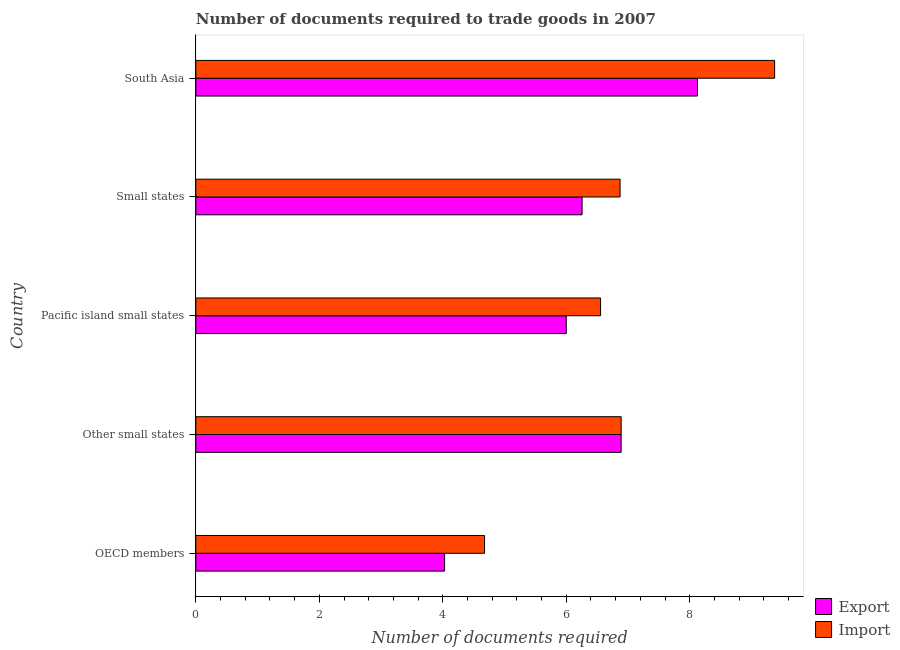How many groups of bars are there?
Your answer should be very brief. 5. Are the number of bars per tick equal to the number of legend labels?
Provide a short and direct response. Yes. How many bars are there on the 3rd tick from the top?
Offer a very short reply. 2. What is the number of documents required to export goods in South Asia?
Provide a succinct answer. 8.12. Across all countries, what is the maximum number of documents required to import goods?
Provide a short and direct response. 9.38. Across all countries, what is the minimum number of documents required to import goods?
Keep it short and to the point. 4.68. What is the total number of documents required to export goods in the graph?
Your response must be concise. 31.3. What is the difference between the number of documents required to export goods in Pacific island small states and that in Small states?
Your answer should be compact. -0.26. What is the difference between the number of documents required to import goods in South Asia and the number of documents required to export goods in Small states?
Make the answer very short. 3.12. What is the average number of documents required to import goods per country?
Make the answer very short. 6.87. What is the difference between the number of documents required to import goods and number of documents required to export goods in OECD members?
Provide a short and direct response. 0.65. What is the ratio of the number of documents required to export goods in Pacific island small states to that in South Asia?
Your answer should be very brief. 0.74. Is the number of documents required to import goods in OECD members less than that in Small states?
Your response must be concise. Yes. What is the difference between the highest and the second highest number of documents required to export goods?
Your answer should be compact. 1.24. In how many countries, is the number of documents required to export goods greater than the average number of documents required to export goods taken over all countries?
Offer a very short reply. 2. Is the sum of the number of documents required to export goods in OECD members and South Asia greater than the maximum number of documents required to import goods across all countries?
Provide a succinct answer. Yes. What does the 2nd bar from the top in Small states represents?
Offer a terse response. Export. What does the 2nd bar from the bottom in OECD members represents?
Give a very brief answer. Import. Are all the bars in the graph horizontal?
Keep it short and to the point. Yes. How many countries are there in the graph?
Ensure brevity in your answer.  5. Does the graph contain any zero values?
Offer a terse response. No. Where does the legend appear in the graph?
Offer a terse response. Bottom right. How many legend labels are there?
Your answer should be very brief. 2. How are the legend labels stacked?
Give a very brief answer. Vertical. What is the title of the graph?
Your response must be concise. Number of documents required to trade goods in 2007. What is the label or title of the X-axis?
Give a very brief answer. Number of documents required. What is the Number of documents required in Export in OECD members?
Give a very brief answer. 4.03. What is the Number of documents required in Import in OECD members?
Give a very brief answer. 4.68. What is the Number of documents required of Export in Other small states?
Give a very brief answer. 6.89. What is the Number of documents required in Import in Other small states?
Provide a short and direct response. 6.89. What is the Number of documents required in Export in Pacific island small states?
Offer a very short reply. 6. What is the Number of documents required of Import in Pacific island small states?
Your response must be concise. 6.56. What is the Number of documents required in Export in Small states?
Ensure brevity in your answer.  6.26. What is the Number of documents required in Import in Small states?
Your response must be concise. 6.87. What is the Number of documents required of Export in South Asia?
Your answer should be compact. 8.12. What is the Number of documents required in Import in South Asia?
Your answer should be compact. 9.38. Across all countries, what is the maximum Number of documents required of Export?
Your response must be concise. 8.12. Across all countries, what is the maximum Number of documents required of Import?
Your response must be concise. 9.38. Across all countries, what is the minimum Number of documents required of Export?
Provide a succinct answer. 4.03. Across all countries, what is the minimum Number of documents required of Import?
Ensure brevity in your answer.  4.68. What is the total Number of documents required of Export in the graph?
Make the answer very short. 31.3. What is the total Number of documents required of Import in the graph?
Offer a terse response. 34.37. What is the difference between the Number of documents required of Export in OECD members and that in Other small states?
Ensure brevity in your answer.  -2.86. What is the difference between the Number of documents required of Import in OECD members and that in Other small states?
Your answer should be very brief. -2.21. What is the difference between the Number of documents required of Export in OECD members and that in Pacific island small states?
Your answer should be compact. -1.97. What is the difference between the Number of documents required of Import in OECD members and that in Pacific island small states?
Your answer should be compact. -1.88. What is the difference between the Number of documents required of Export in OECD members and that in Small states?
Your answer should be very brief. -2.23. What is the difference between the Number of documents required of Import in OECD members and that in Small states?
Ensure brevity in your answer.  -2.2. What is the difference between the Number of documents required in Export in OECD members and that in South Asia?
Give a very brief answer. -4.1. What is the difference between the Number of documents required of Import in OECD members and that in South Asia?
Your response must be concise. -4.7. What is the difference between the Number of documents required in Export in Other small states and that in Small states?
Make the answer very short. 0.63. What is the difference between the Number of documents required of Import in Other small states and that in Small states?
Provide a short and direct response. 0.02. What is the difference between the Number of documents required of Export in Other small states and that in South Asia?
Provide a short and direct response. -1.24. What is the difference between the Number of documents required in Import in Other small states and that in South Asia?
Offer a very short reply. -2.49. What is the difference between the Number of documents required of Export in Pacific island small states and that in Small states?
Provide a short and direct response. -0.26. What is the difference between the Number of documents required of Import in Pacific island small states and that in Small states?
Offer a terse response. -0.32. What is the difference between the Number of documents required in Export in Pacific island small states and that in South Asia?
Offer a very short reply. -2.12. What is the difference between the Number of documents required of Import in Pacific island small states and that in South Asia?
Your answer should be compact. -2.82. What is the difference between the Number of documents required in Export in Small states and that in South Asia?
Give a very brief answer. -1.87. What is the difference between the Number of documents required in Import in Small states and that in South Asia?
Offer a terse response. -2.5. What is the difference between the Number of documents required in Export in OECD members and the Number of documents required in Import in Other small states?
Provide a short and direct response. -2.86. What is the difference between the Number of documents required of Export in OECD members and the Number of documents required of Import in Pacific island small states?
Your answer should be compact. -2.53. What is the difference between the Number of documents required in Export in OECD members and the Number of documents required in Import in Small states?
Your response must be concise. -2.84. What is the difference between the Number of documents required of Export in OECD members and the Number of documents required of Import in South Asia?
Make the answer very short. -5.35. What is the difference between the Number of documents required of Export in Other small states and the Number of documents required of Import in Pacific island small states?
Provide a short and direct response. 0.33. What is the difference between the Number of documents required in Export in Other small states and the Number of documents required in Import in Small states?
Provide a short and direct response. 0.02. What is the difference between the Number of documents required of Export in Other small states and the Number of documents required of Import in South Asia?
Give a very brief answer. -2.49. What is the difference between the Number of documents required in Export in Pacific island small states and the Number of documents required in Import in Small states?
Provide a succinct answer. -0.87. What is the difference between the Number of documents required of Export in Pacific island small states and the Number of documents required of Import in South Asia?
Provide a succinct answer. -3.38. What is the difference between the Number of documents required of Export in Small states and the Number of documents required of Import in South Asia?
Provide a succinct answer. -3.12. What is the average Number of documents required in Export per country?
Offer a very short reply. 6.26. What is the average Number of documents required in Import per country?
Your response must be concise. 6.87. What is the difference between the Number of documents required of Export and Number of documents required of Import in OECD members?
Provide a succinct answer. -0.65. What is the difference between the Number of documents required in Export and Number of documents required in Import in Pacific island small states?
Ensure brevity in your answer.  -0.56. What is the difference between the Number of documents required of Export and Number of documents required of Import in Small states?
Your answer should be compact. -0.62. What is the difference between the Number of documents required of Export and Number of documents required of Import in South Asia?
Your answer should be very brief. -1.25. What is the ratio of the Number of documents required of Export in OECD members to that in Other small states?
Offer a terse response. 0.58. What is the ratio of the Number of documents required in Import in OECD members to that in Other small states?
Make the answer very short. 0.68. What is the ratio of the Number of documents required in Export in OECD members to that in Pacific island small states?
Make the answer very short. 0.67. What is the ratio of the Number of documents required in Import in OECD members to that in Pacific island small states?
Your answer should be compact. 0.71. What is the ratio of the Number of documents required in Export in OECD members to that in Small states?
Offer a very short reply. 0.64. What is the ratio of the Number of documents required in Import in OECD members to that in Small states?
Provide a succinct answer. 0.68. What is the ratio of the Number of documents required in Export in OECD members to that in South Asia?
Give a very brief answer. 0.5. What is the ratio of the Number of documents required in Import in OECD members to that in South Asia?
Offer a very short reply. 0.5. What is the ratio of the Number of documents required in Export in Other small states to that in Pacific island small states?
Ensure brevity in your answer.  1.15. What is the ratio of the Number of documents required of Import in Other small states to that in Pacific island small states?
Give a very brief answer. 1.05. What is the ratio of the Number of documents required in Export in Other small states to that in Small states?
Your response must be concise. 1.1. What is the ratio of the Number of documents required of Export in Other small states to that in South Asia?
Your answer should be very brief. 0.85. What is the ratio of the Number of documents required of Import in Other small states to that in South Asia?
Offer a terse response. 0.73. What is the ratio of the Number of documents required of Import in Pacific island small states to that in Small states?
Keep it short and to the point. 0.95. What is the ratio of the Number of documents required in Export in Pacific island small states to that in South Asia?
Offer a terse response. 0.74. What is the ratio of the Number of documents required in Import in Pacific island small states to that in South Asia?
Give a very brief answer. 0.7. What is the ratio of the Number of documents required of Export in Small states to that in South Asia?
Make the answer very short. 0.77. What is the ratio of the Number of documents required in Import in Small states to that in South Asia?
Give a very brief answer. 0.73. What is the difference between the highest and the second highest Number of documents required of Export?
Keep it short and to the point. 1.24. What is the difference between the highest and the second highest Number of documents required of Import?
Your answer should be compact. 2.49. What is the difference between the highest and the lowest Number of documents required of Export?
Your answer should be compact. 4.1. What is the difference between the highest and the lowest Number of documents required in Import?
Provide a short and direct response. 4.7. 